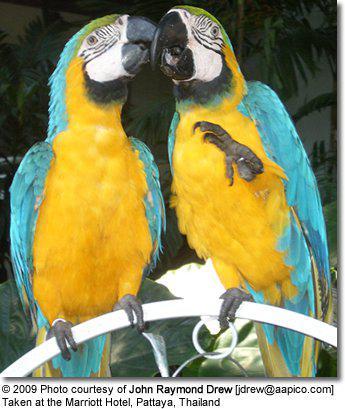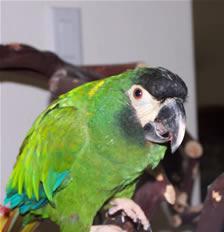The first image is the image on the left, the second image is the image on the right. Evaluate the accuracy of this statement regarding the images: "There are two parrots.". Is it true? Answer yes or no. No. The first image is the image on the left, the second image is the image on the right. Considering the images on both sides, is "There is no more than one bird in each image." valid? Answer yes or no. No. 